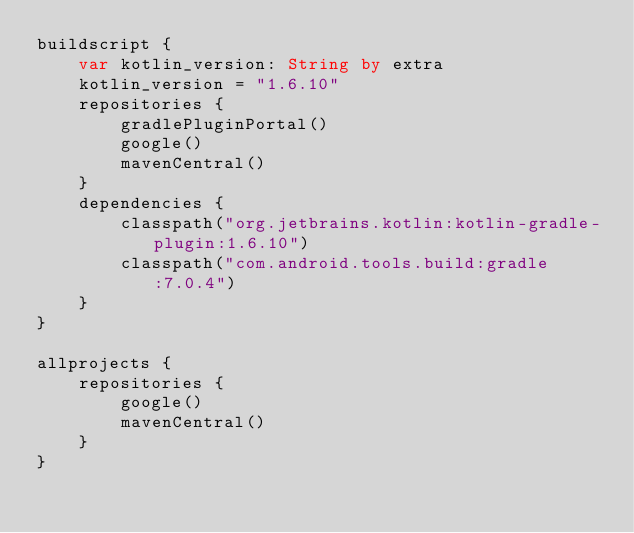<code> <loc_0><loc_0><loc_500><loc_500><_Kotlin_>buildscript {
    var kotlin_version: String by extra
    kotlin_version = "1.6.10"
    repositories {
        gradlePluginPortal()
        google()
        mavenCentral()
    }
    dependencies {
        classpath("org.jetbrains.kotlin:kotlin-gradle-plugin:1.6.10")
        classpath("com.android.tools.build:gradle:7.0.4")
    }
}

allprojects {
    repositories {
        google()
        mavenCentral()
    }
}</code> 